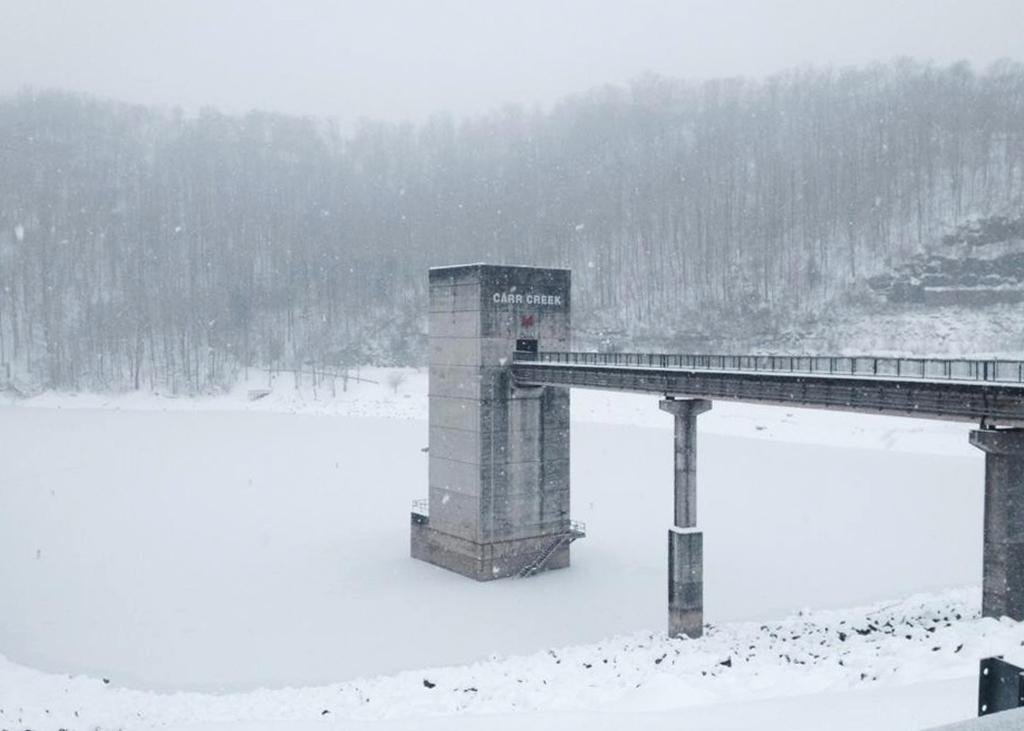What structure is the main subject of the image? There is there a bridge in the image? What are the pillars supporting in the image? The pillars are supporting the bridge. What is the ground condition in the image? There is snow at the bottom of the image. What can be seen in the background of the image? There are trees in the background of the image. What is visible at the top of the image? The sky is visible at the top of the image. Can you tell me how many toothbrushes are hanging on the trees in the image? There are no toothbrushes present in the image; it features a bridge with pillars, snow, trees, and a visible sky. 